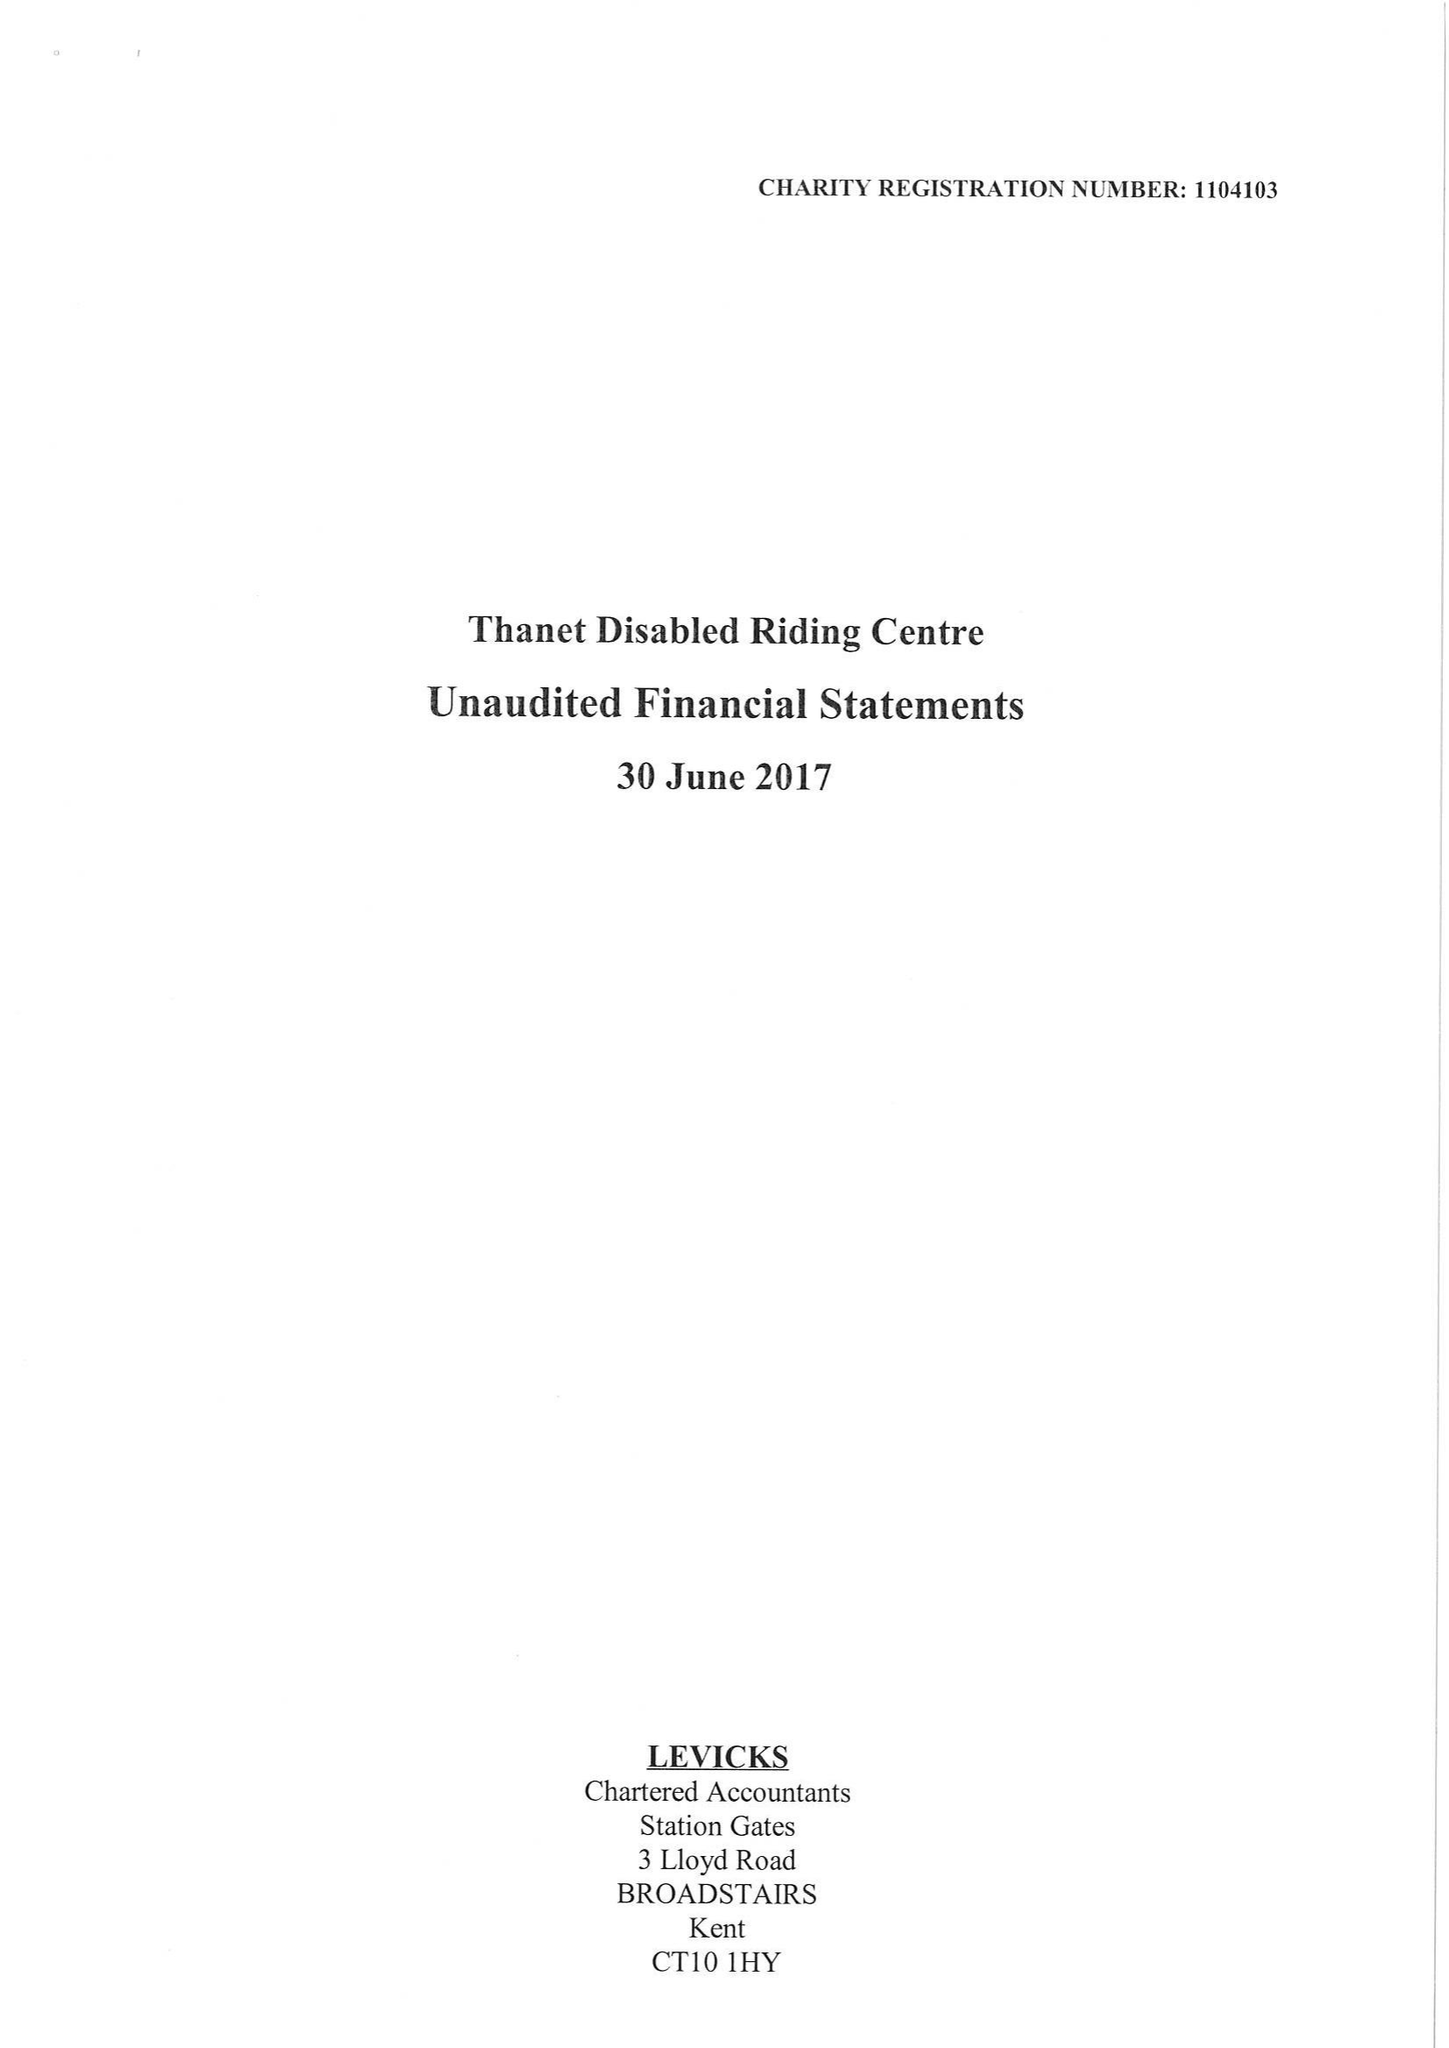What is the value for the charity_number?
Answer the question using a single word or phrase. 1104103 